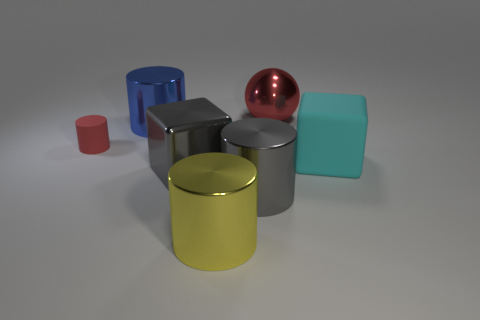Add 3 big metallic spheres. How many objects exist? 10 Subtract all blocks. How many objects are left? 5 Add 2 large blue cylinders. How many large blue cylinders exist? 3 Subtract 0 purple cylinders. How many objects are left? 7 Subtract all purple matte cylinders. Subtract all big red metallic things. How many objects are left? 6 Add 5 matte blocks. How many matte blocks are left? 6 